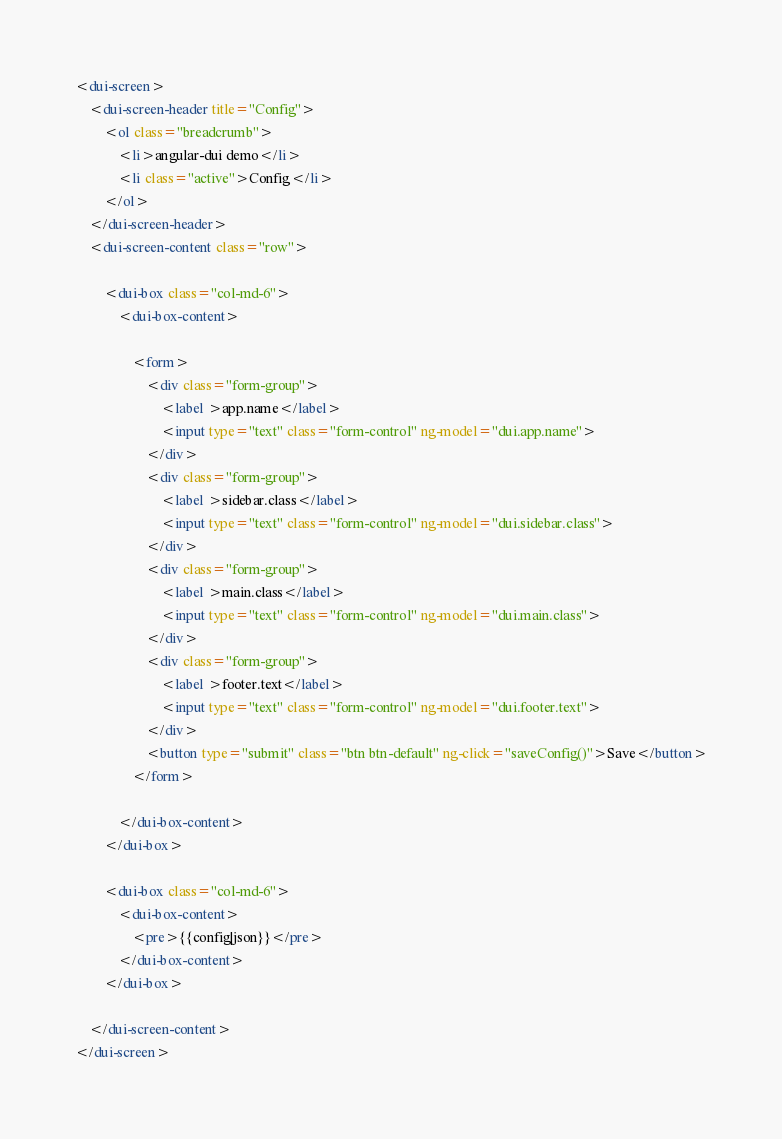Convert code to text. <code><loc_0><loc_0><loc_500><loc_500><_HTML_><dui-screen>
    <dui-screen-header title="Config">
        <ol class="breadcrumb">
            <li>angular-dui demo</li>
            <li class="active">Config</li>
        </ol>
    </dui-screen-header>
    <dui-screen-content class="row">

        <dui-box class="col-md-6">
            <dui-box-content>

                <form>
                    <div class="form-group">
                        <label >app.name</label>
                        <input type="text" class="form-control" ng-model="dui.app.name">
                    </div>
                    <div class="form-group">
                        <label >sidebar.class</label>
                        <input type="text" class="form-control" ng-model="dui.sidebar.class">
                    </div>
                    <div class="form-group">
                        <label >main.class</label>
                        <input type="text" class="form-control" ng-model="dui.main.class">
                    </div>
                    <div class="form-group">
                        <label >footer.text</label>
                        <input type="text" class="form-control" ng-model="dui.footer.text">
                    </div>
                    <button type="submit" class="btn btn-default" ng-click="saveConfig()">Save</button>
                </form>

            </dui-box-content>
        </dui-box>

        <dui-box class="col-md-6">
            <dui-box-content>
                <pre>{{config|json}}</pre>
            </dui-box-content>
        </dui-box>

    </dui-screen-content>
</dui-screen>
</code> 